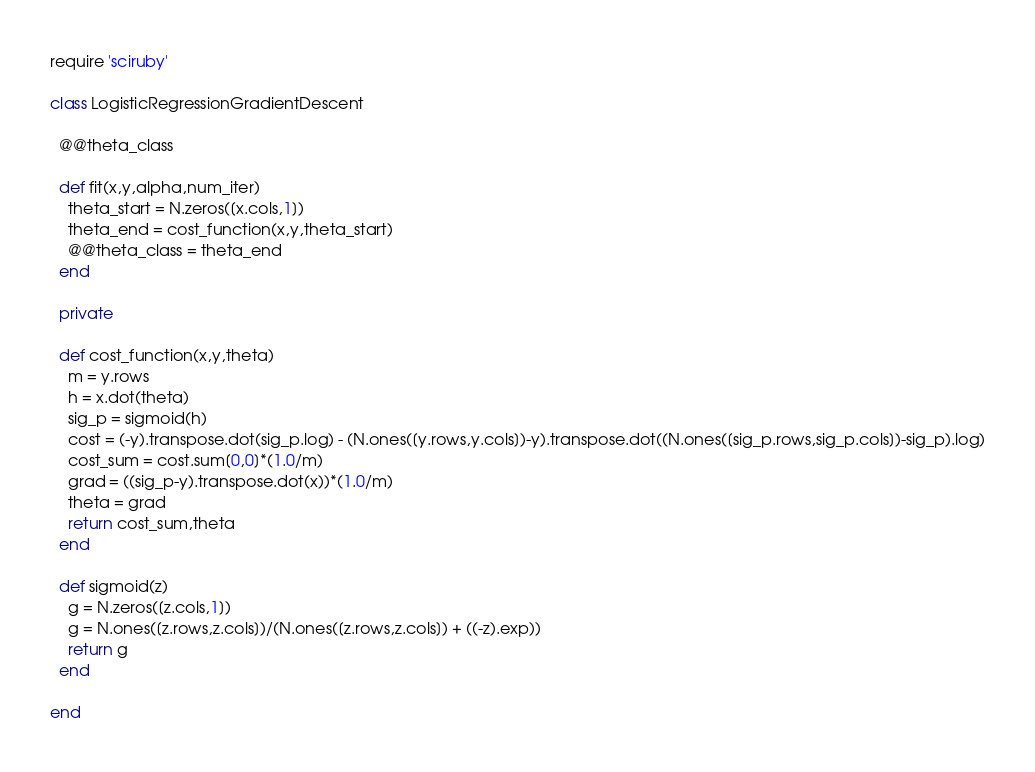<code> <loc_0><loc_0><loc_500><loc_500><_Ruby_>require 'sciruby'

class LogisticRegressionGradientDescent

  @@theta_class

  def fit(x,y,alpha,num_iter)
    theta_start = N.zeros([x.cols,1])
    theta_end = cost_function(x,y,theta_start)
    @@theta_class = theta_end
  end

  private

  def cost_function(x,y,theta)
    m = y.rows
    h = x.dot(theta)
    sig_p = sigmoid(h)
    cost = (-y).transpose.dot(sig_p.log) - (N.ones([y.rows,y.cols])-y).transpose.dot((N.ones([sig_p.rows,sig_p.cols])-sig_p).log)
    cost_sum = cost.sum[0,0]*(1.0/m)
    grad = ((sig_p-y).transpose.dot(x))*(1.0/m)
    theta = grad
    return cost_sum,theta
  end

  def sigmoid(z)
    g = N.zeros([z.cols,1])
    g = N.ones([z.rows,z.cols])/(N.ones([z.rows,z.cols]) + ((-z).exp))
    return g
  end

end
</code> 